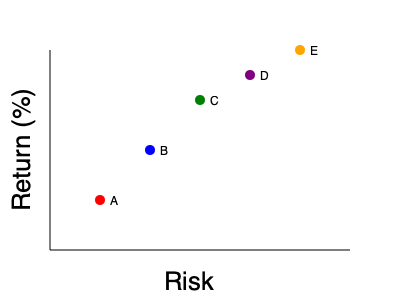Based on the scatter plot of risk vs. return for different investments (A, B, C, D, E), which investment would be most suitable for a risk-averse investor seeking moderate returns? To answer this question, we need to analyze the risk-return tradeoff for each investment:

1. Understand the axes:
   - X-axis represents risk (increasing from left to right)
   - Y-axis represents return (increasing from bottom to top)

2. Analyze each investment:
   A: Low risk, low return
   B: Moderate risk, moderate return
   C: Moderate-high risk, moderate-high return
   D: High risk, high return
   E: Very high risk, very high return

3. Consider the investor's profile:
   - Risk-averse: Prefers lower risk investments
   - Seeking moderate returns: Willing to accept some risk for better returns

4. Compare investments:
   - A is too conservative (lowest risk, but also lowest return)
   - C, D, and E are too risky for a risk-averse investor
   - B offers a balanced risk-return profile

5. Conclusion:
   Investment B provides moderate returns while maintaining a relatively low risk level, making it the most suitable option for a risk-averse investor seeking moderate returns.
Answer: B 